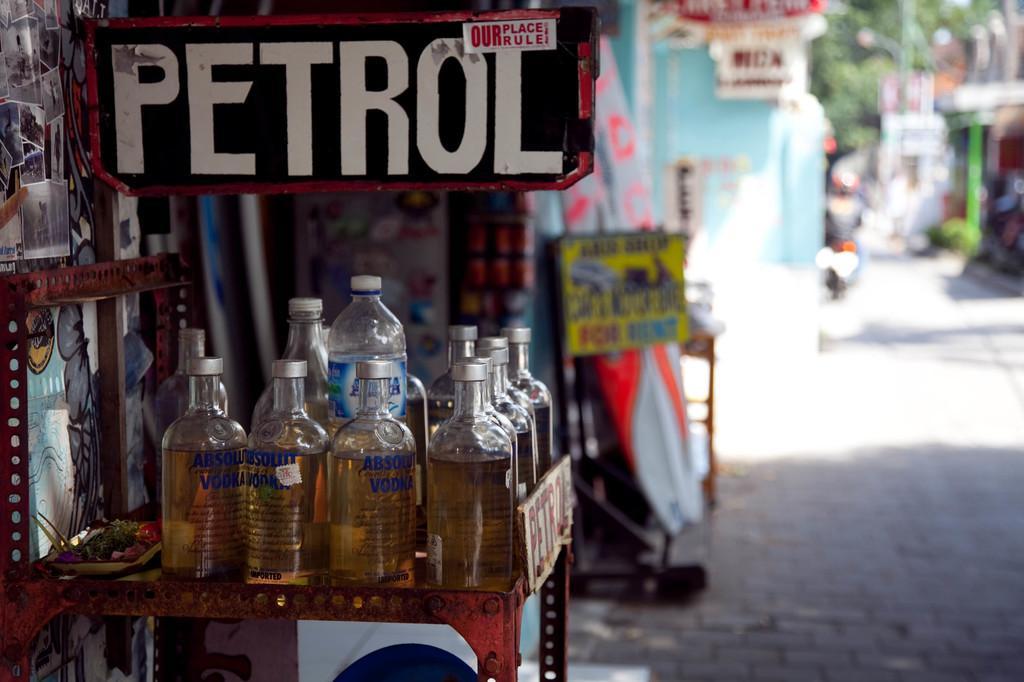Please provide a concise description of this image. In this picture there are a tray of bottles kept and there is a nameplate over here, there are some decorative items over here and this is the walkway this is a person going on a motorcycle, there is a tree 